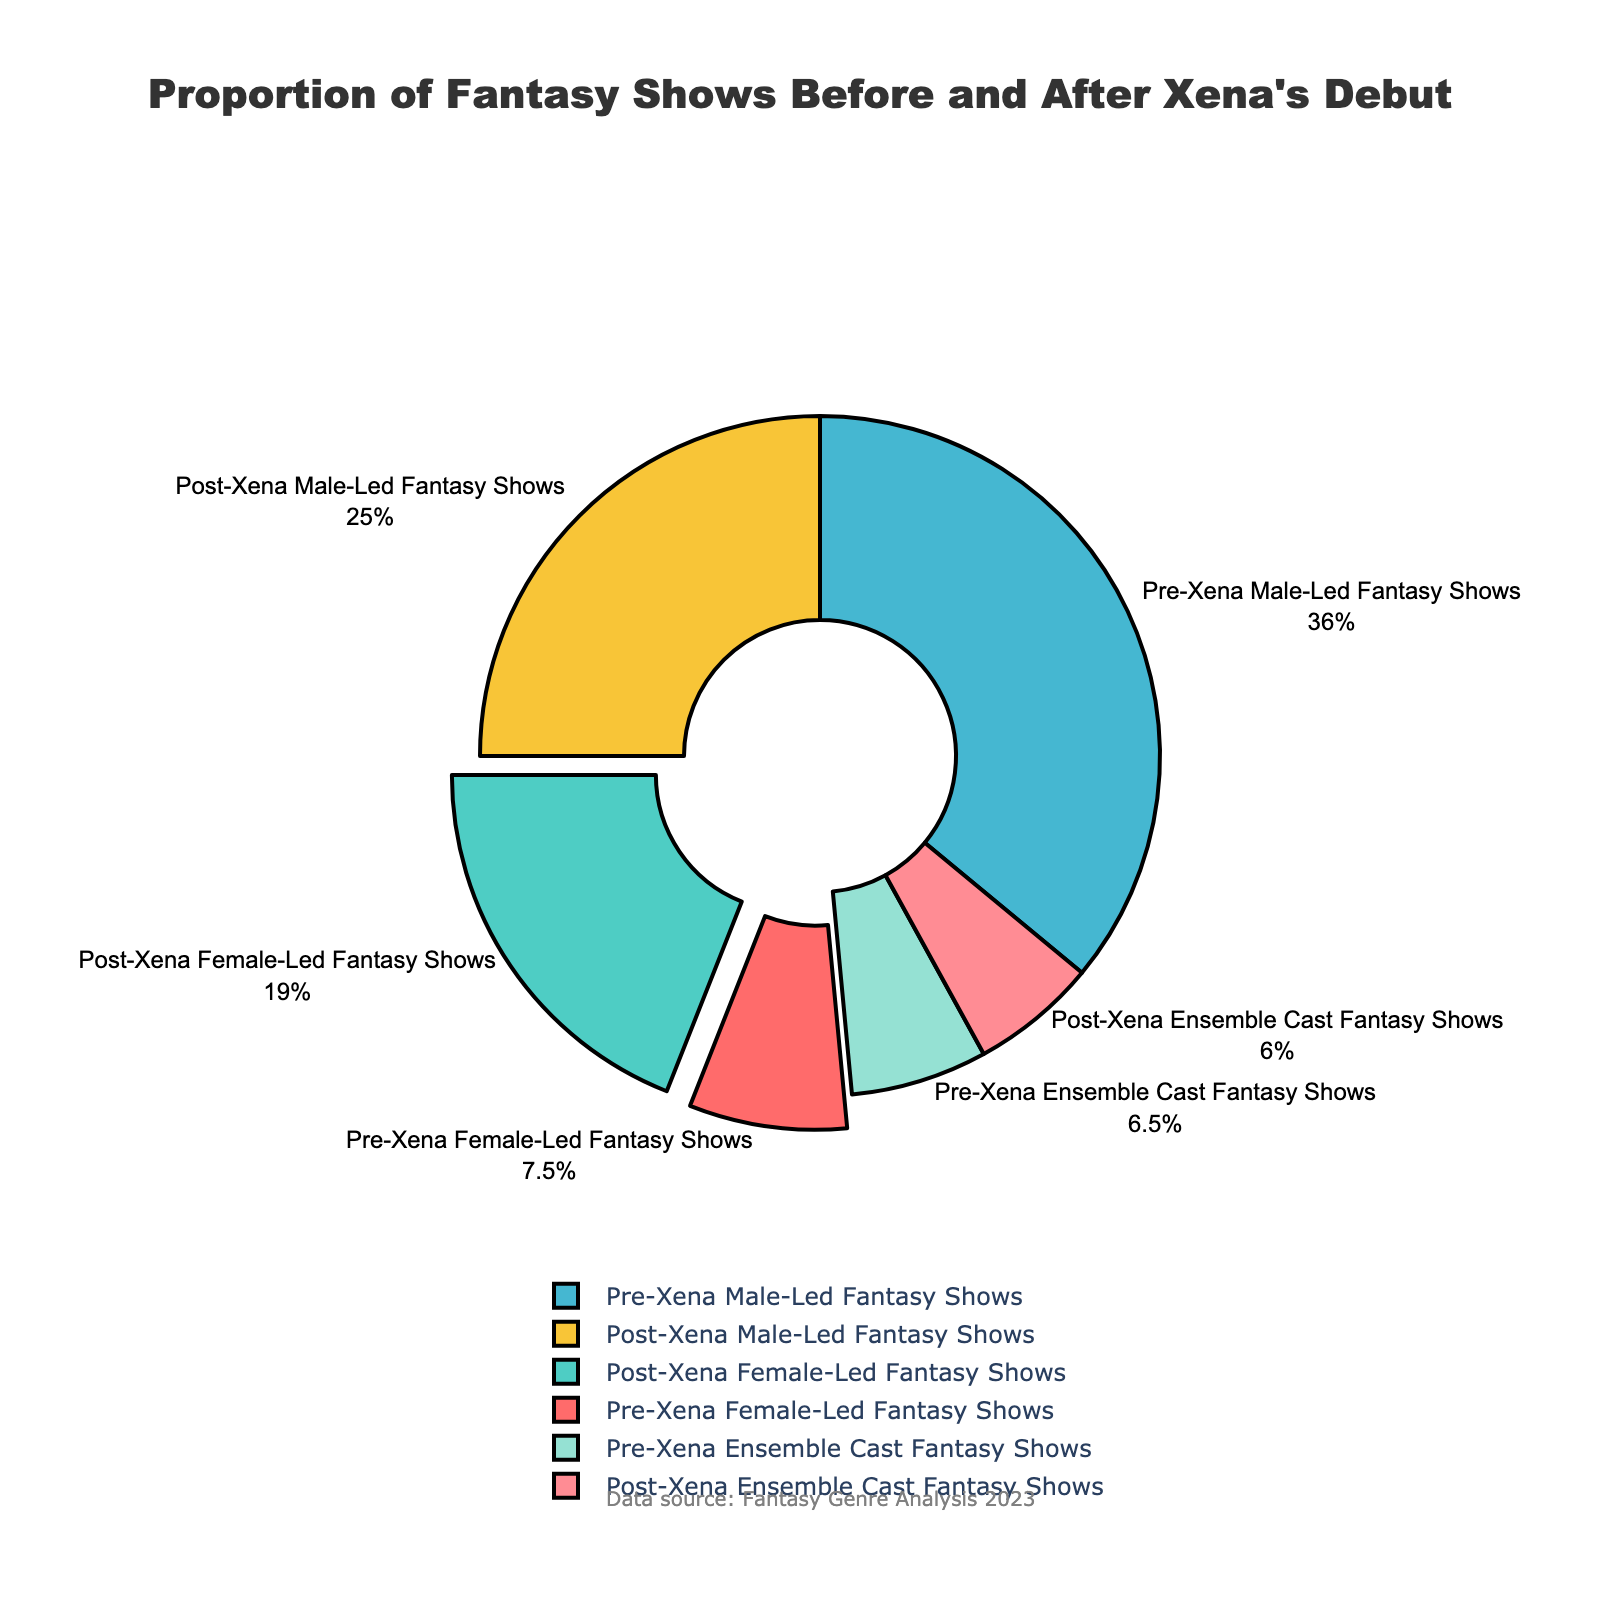What is the percentage of female-led fantasy shows before and after Xena's debut? The chart shows the percentage for female-led fantasy shows in two categories: Pre-Xena and Post-Xena. The Pre-Xena category has 15%, and the Post-Xena category has 38%.
Answer: Before: 15%, After: 38% How much did the percentage of female-led fantasy shows increase after Xena's debut? Subtract the percentage of Pre-Xena Female-Led Fantasy Shows from the percentage of Post-Xena Female-Led Fantasy Shows: 38% - 15% = 23%.
Answer: 23% Compare the percentage of male-led fantasy shows pre- and post-Xena's debut. Which period had a higher percentage? The chart shows that Pre-Xena Male-Led Fantasy Shows had 72%, while Post-Xena Male-Led Fantasy Shows had 50%. Since 72% is greater than 50%, the Pre-Xena period had a higher percentage of male-led shows.
Answer: Pre-Xena What is the combined percentage of ensemble cast fantasy shows before and after Xena's debut? Add the percentages of Pre-Xena Ensemble Cast Fantasy Shows and Post-Xena Ensemble Cast Fantasy Shows: 13% + 12% = 25%.
Answer: 25% Which category saw the biggest percentage decrease after Xena's debut? Compare the percentage changes from pre- to post-Xena for each category. Male-led fantasy shows decreased from 72% to 50% (a 22% decrease), which is the largest decrease among the categories.
Answer: Male-led fantasy shows What percentage represents male-led and ensemble cast fantasy shows combined post-Xena? Add the percentages for Post-Xena Male-Led Fantasy Shows and Post-Xena Ensemble Cast Fantasy Shows: 50% + 12% = 62%.
Answer: 62% Visually, which segment appears to be the largest? The largest segment visually is the Pre-Xena Male-Led Fantasy Shows, which is represented by the 72% portion of the pie chart.
Answer: Pre-Xena Male-Led Fantasy Shows How does the proportion of female-led shows post-Xena compare to the combined proportion of pre-Xena male-led and ensemble cast shows? The combined proportion of Pre-Xena Male-Led Fantasy Shows and Pre-Xena Ensemble Cast Fantasy Shows is 72% + 13% = 85%. The percentage of Post-Xena Female-Led Fantasy Shows is 38%, which is less than 85%.
Answer: Less than 85% What is the difference between the combined percentages of male-led and female-led fantasy shows post-Xena and pre-Xena? Calculate the combined percentages: Post-Xena (50% male-led + 38% female-led = 88%) and Pre-Xena (72% male-led + 15% female-led = 87%). The difference is 88% - 87% = 1%.
Answer: 1% How much lower is the percentage of ensemble cast fantasy shows post-Xena compared to pre-Xena? Subtract the percentage of Post-Xena Ensemble Cast Fantasy Shows from the percentage of Pre-Xena Ensemble Cast Fantasy Shows: 13% - 12% = 1%.
Answer: 1% 